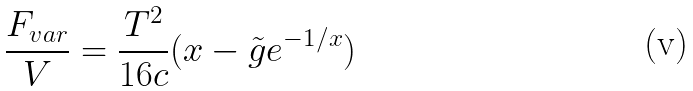<formula> <loc_0><loc_0><loc_500><loc_500>\frac { F _ { v a r } } { V } = \frac { T ^ { 2 } } { 1 6 c } ( x - \tilde { g } e ^ { - 1 / x } )</formula> 